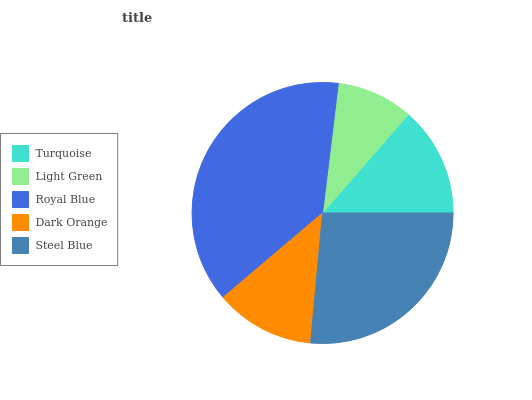Is Light Green the minimum?
Answer yes or no. Yes. Is Royal Blue the maximum?
Answer yes or no. Yes. Is Royal Blue the minimum?
Answer yes or no. No. Is Light Green the maximum?
Answer yes or no. No. Is Royal Blue greater than Light Green?
Answer yes or no. Yes. Is Light Green less than Royal Blue?
Answer yes or no. Yes. Is Light Green greater than Royal Blue?
Answer yes or no. No. Is Royal Blue less than Light Green?
Answer yes or no. No. Is Turquoise the high median?
Answer yes or no. Yes. Is Turquoise the low median?
Answer yes or no. Yes. Is Light Green the high median?
Answer yes or no. No. Is Dark Orange the low median?
Answer yes or no. No. 